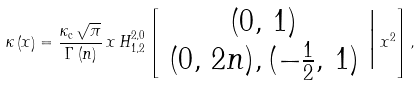<formula> <loc_0><loc_0><loc_500><loc_500>\kappa \left ( x \right ) = \frac { \kappa _ { \text {c} } \, \sqrt { \pi } } { \Gamma \left ( n \right ) } \, x \, H _ { 1 , 2 } ^ { 2 , 0 } \left [ \begin{array} { c } ( 0 , \, 1 ) \\ ( 0 , \, 2 n ) , ( - \frac { 1 } { 2 } , \, 1 ) \end{array} \Big | \, x ^ { 2 } \right ] ,</formula> 